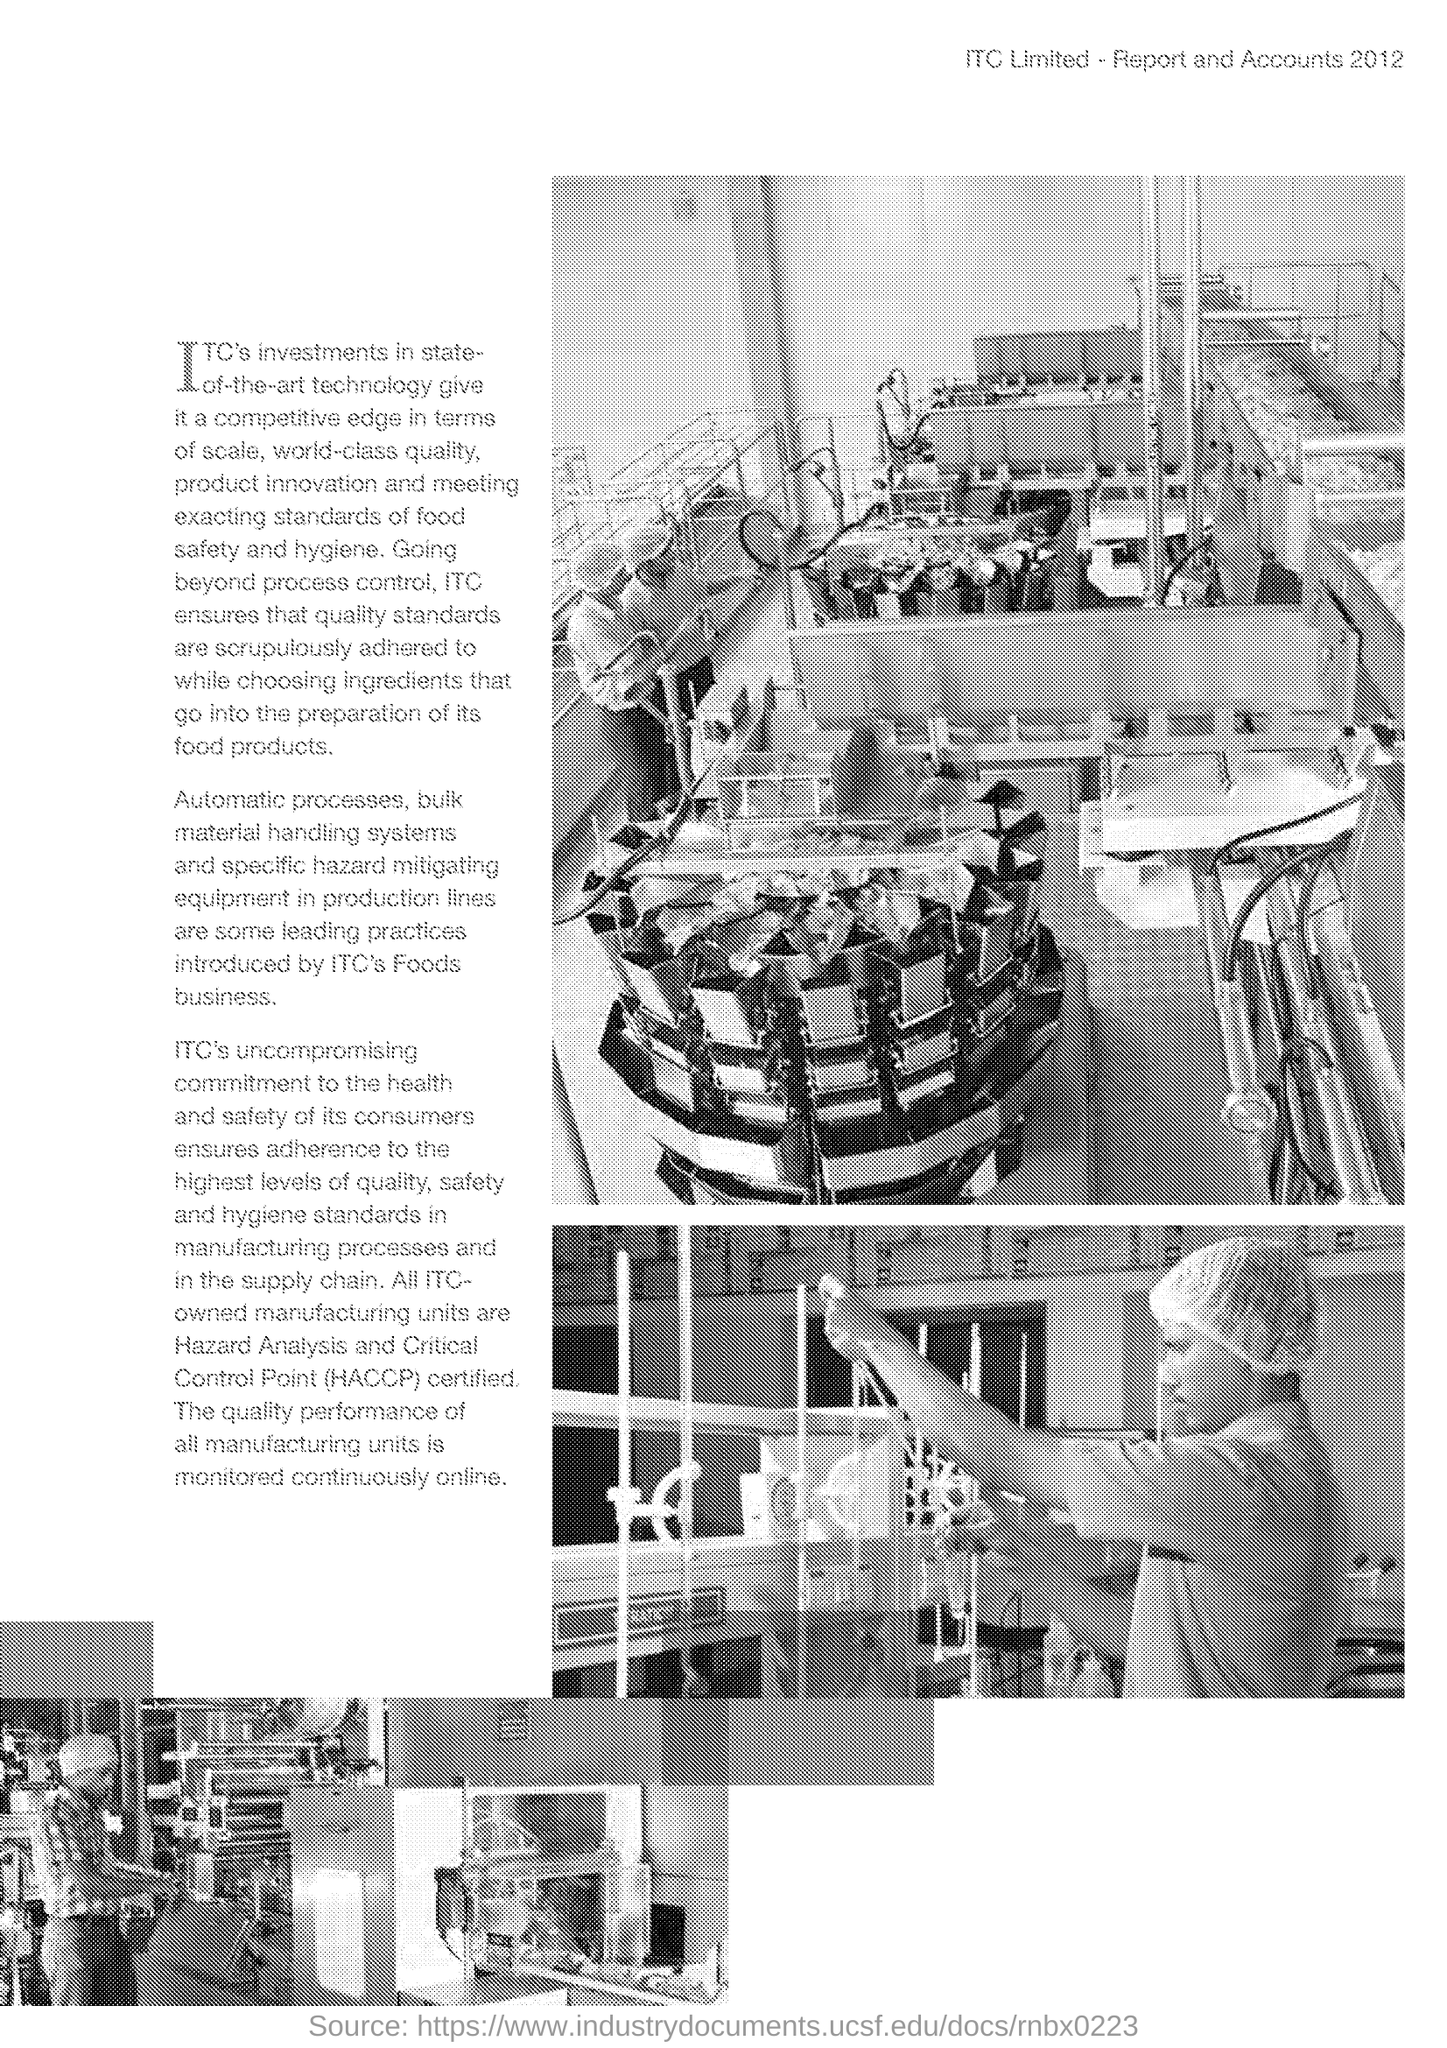What is journal's name printed on top of page?
Provide a succinct answer. Itc limited - report and accounts 2012. 